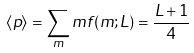<formula> <loc_0><loc_0><loc_500><loc_500>\langle p \rangle = \sum _ { m } m f ( m ; L ) = \frac { L + 1 } { 4 }</formula> 